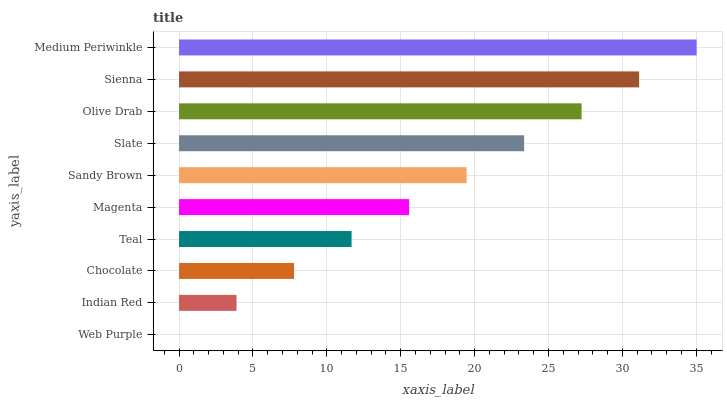Is Web Purple the minimum?
Answer yes or no. Yes. Is Medium Periwinkle the maximum?
Answer yes or no. Yes. Is Indian Red the minimum?
Answer yes or no. No. Is Indian Red the maximum?
Answer yes or no. No. Is Indian Red greater than Web Purple?
Answer yes or no. Yes. Is Web Purple less than Indian Red?
Answer yes or no. Yes. Is Web Purple greater than Indian Red?
Answer yes or no. No. Is Indian Red less than Web Purple?
Answer yes or no. No. Is Sandy Brown the high median?
Answer yes or no. Yes. Is Magenta the low median?
Answer yes or no. Yes. Is Slate the high median?
Answer yes or no. No. Is Sienna the low median?
Answer yes or no. No. 